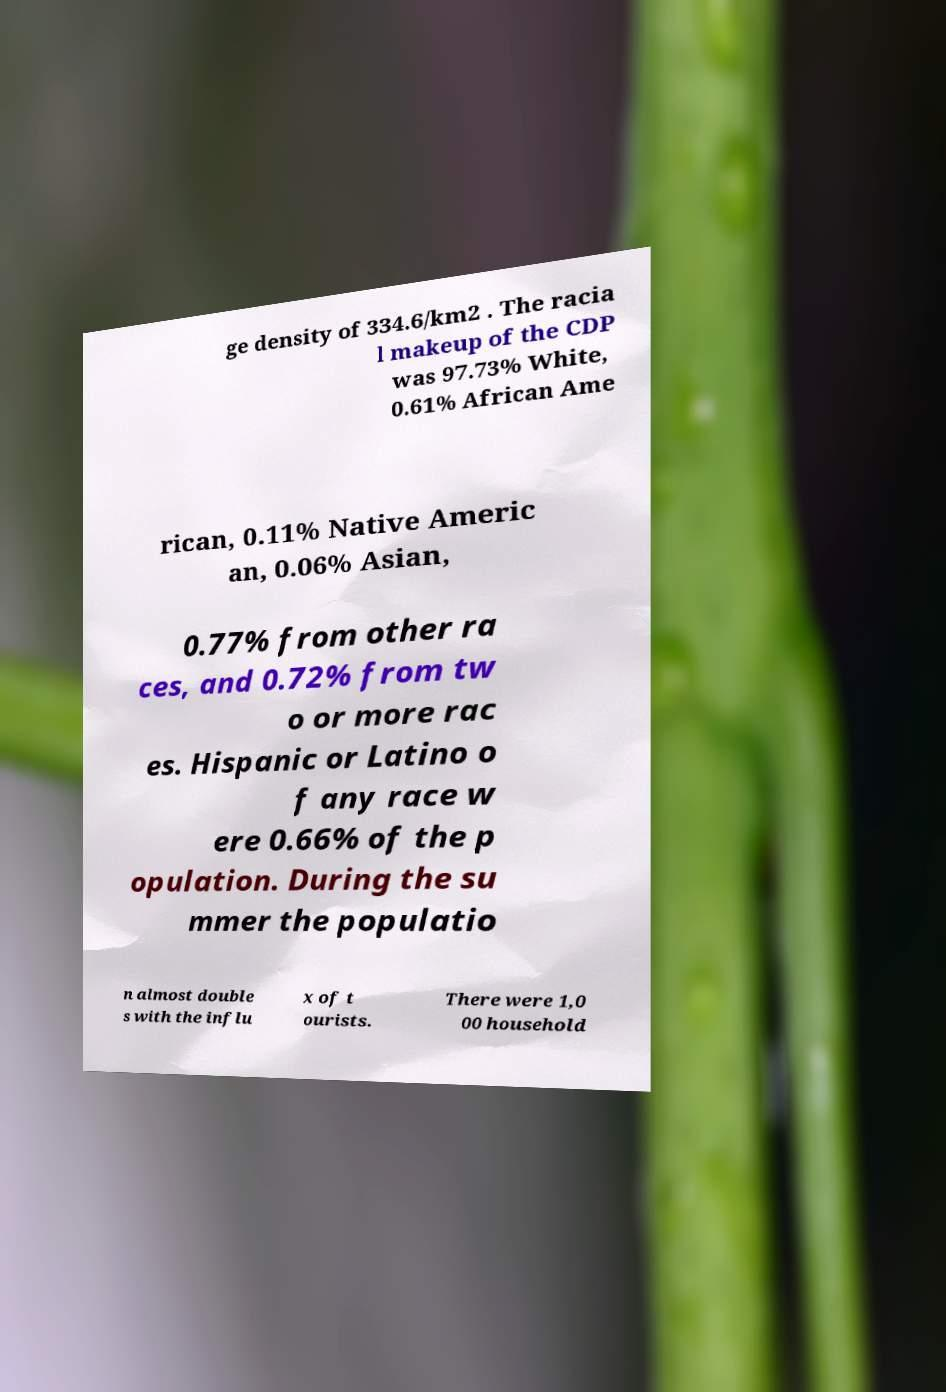I need the written content from this picture converted into text. Can you do that? ge density of 334.6/km2 . The racia l makeup of the CDP was 97.73% White, 0.61% African Ame rican, 0.11% Native Americ an, 0.06% Asian, 0.77% from other ra ces, and 0.72% from tw o or more rac es. Hispanic or Latino o f any race w ere 0.66% of the p opulation. During the su mmer the populatio n almost double s with the influ x of t ourists. There were 1,0 00 household 